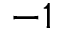Convert formula to latex. <formula><loc_0><loc_0><loc_500><loc_500>- 1</formula> 